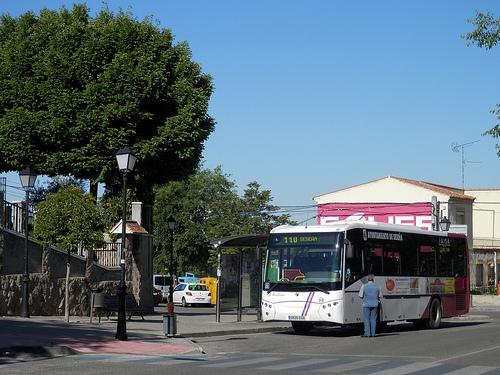In the context of the image, what might the person standing by the bus be doing or waiting for? The person might be waiting to board the transit bus or standing nearby to use the bus service. Please describe the position and appearance of any tree visible in the image. There is a tall tree on the left side of the image with a height of 212 pixels. Mention three objects or elements that can be found near the bus in the image. person in blue, red side walk, and white hatchback parked nearby What is the color of the sky in the image and what kind of natural element can be observed? The sky is blue with white clouds scattered throughout. Is there any street furniture visible in the image, and if so, what is it? Yes, there is a street lamp located over the street in the image. List five objects present in the image. transit bus, white clouds, tall tree, street lamp, large pink sign What is the color of the hatchback in the image, and where is it located? The hatchback is white and is located in a parking lot. What type of vehicle is prominently featured in the image? There is a white transit bus prominently featured in the image. Can you identify any signage or text visible in the image? If so, what are they? There is a large pink sign on a building and a green digital read out on the bus. Identify and describe one notable detail about the bus in the image. There is a green digital read out visible on the front of the white transit bus. 